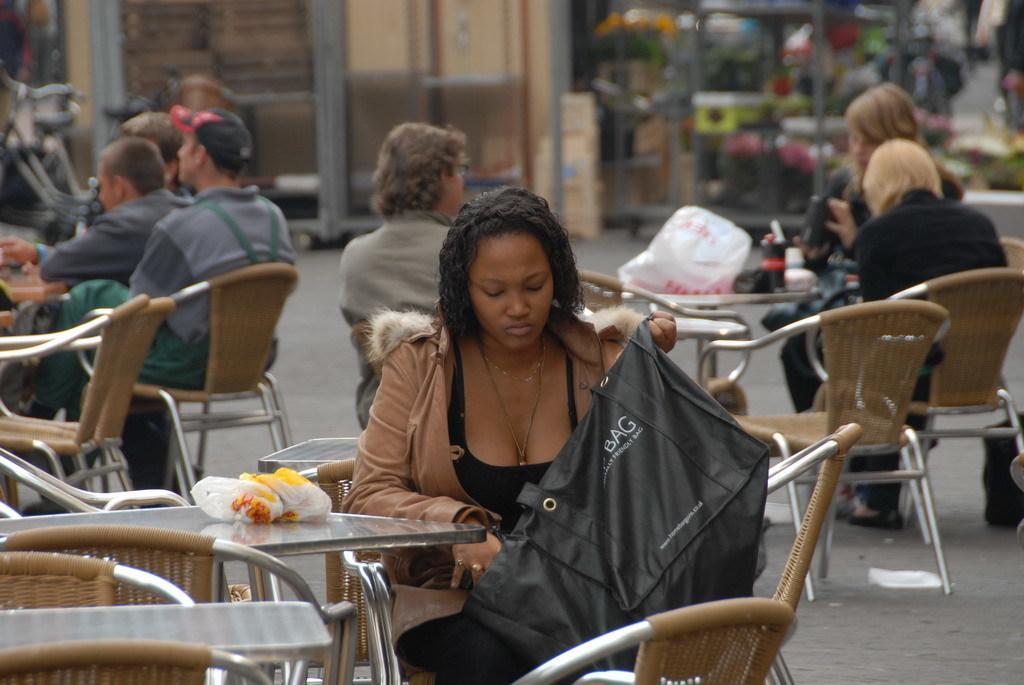Please provide a concise description of this image. there are many tables and chairs. people are seated on the chairs on the road. behind them there are buildings. the person at the front is holding a black color bag. 